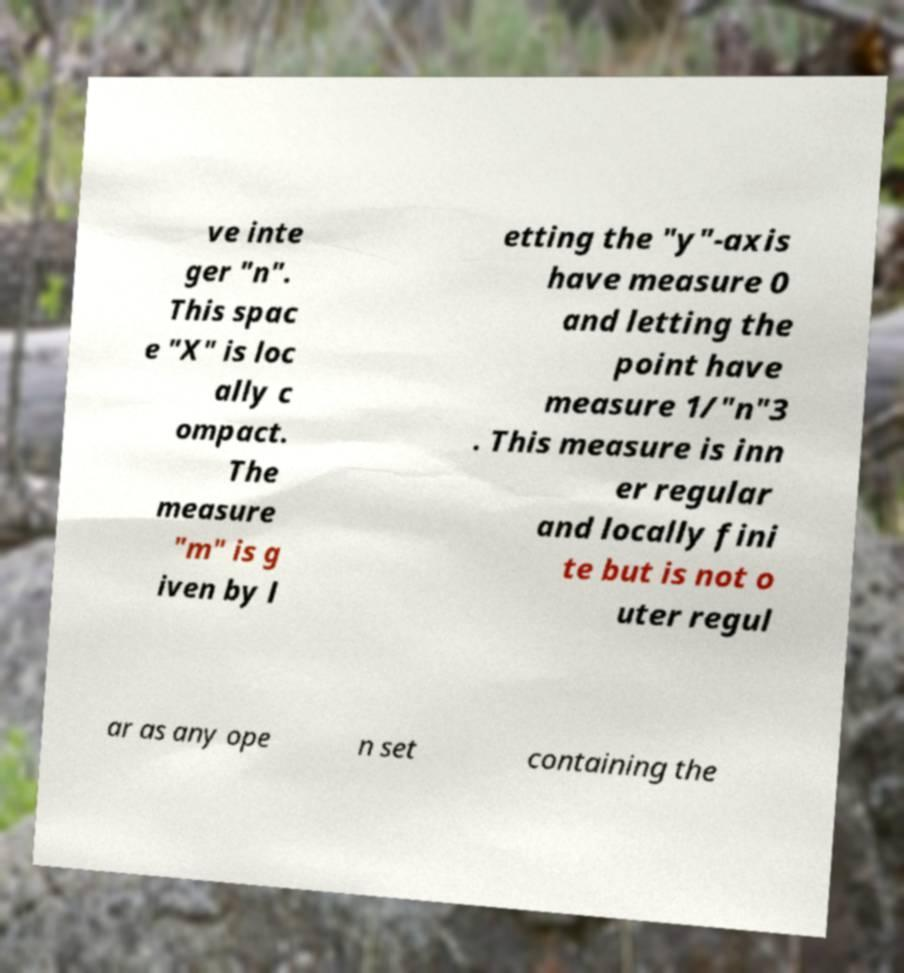Could you extract and type out the text from this image? ve inte ger "n". This spac e "X" is loc ally c ompact. The measure "m" is g iven by l etting the "y"-axis have measure 0 and letting the point have measure 1/"n"3 . This measure is inn er regular and locally fini te but is not o uter regul ar as any ope n set containing the 